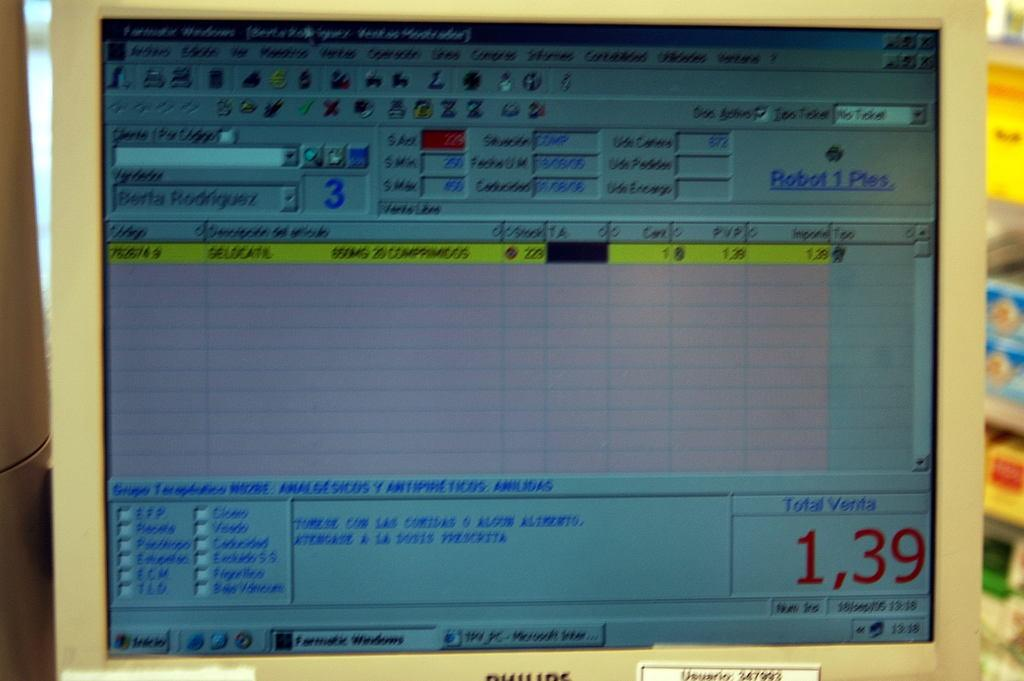<image>
Render a clear and concise summary of the photo. A computer screen which shows a numerous icons and blank lined areas and also has the number 1,39 in the lower right corner. 